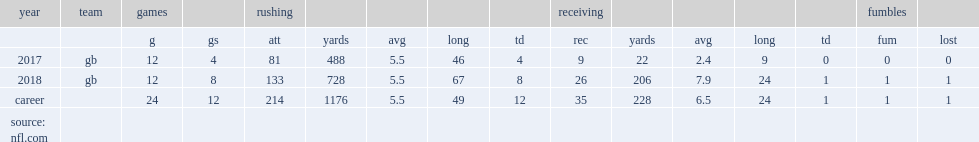How many rushing yards did aaron jones get in 2018? 728.0. 